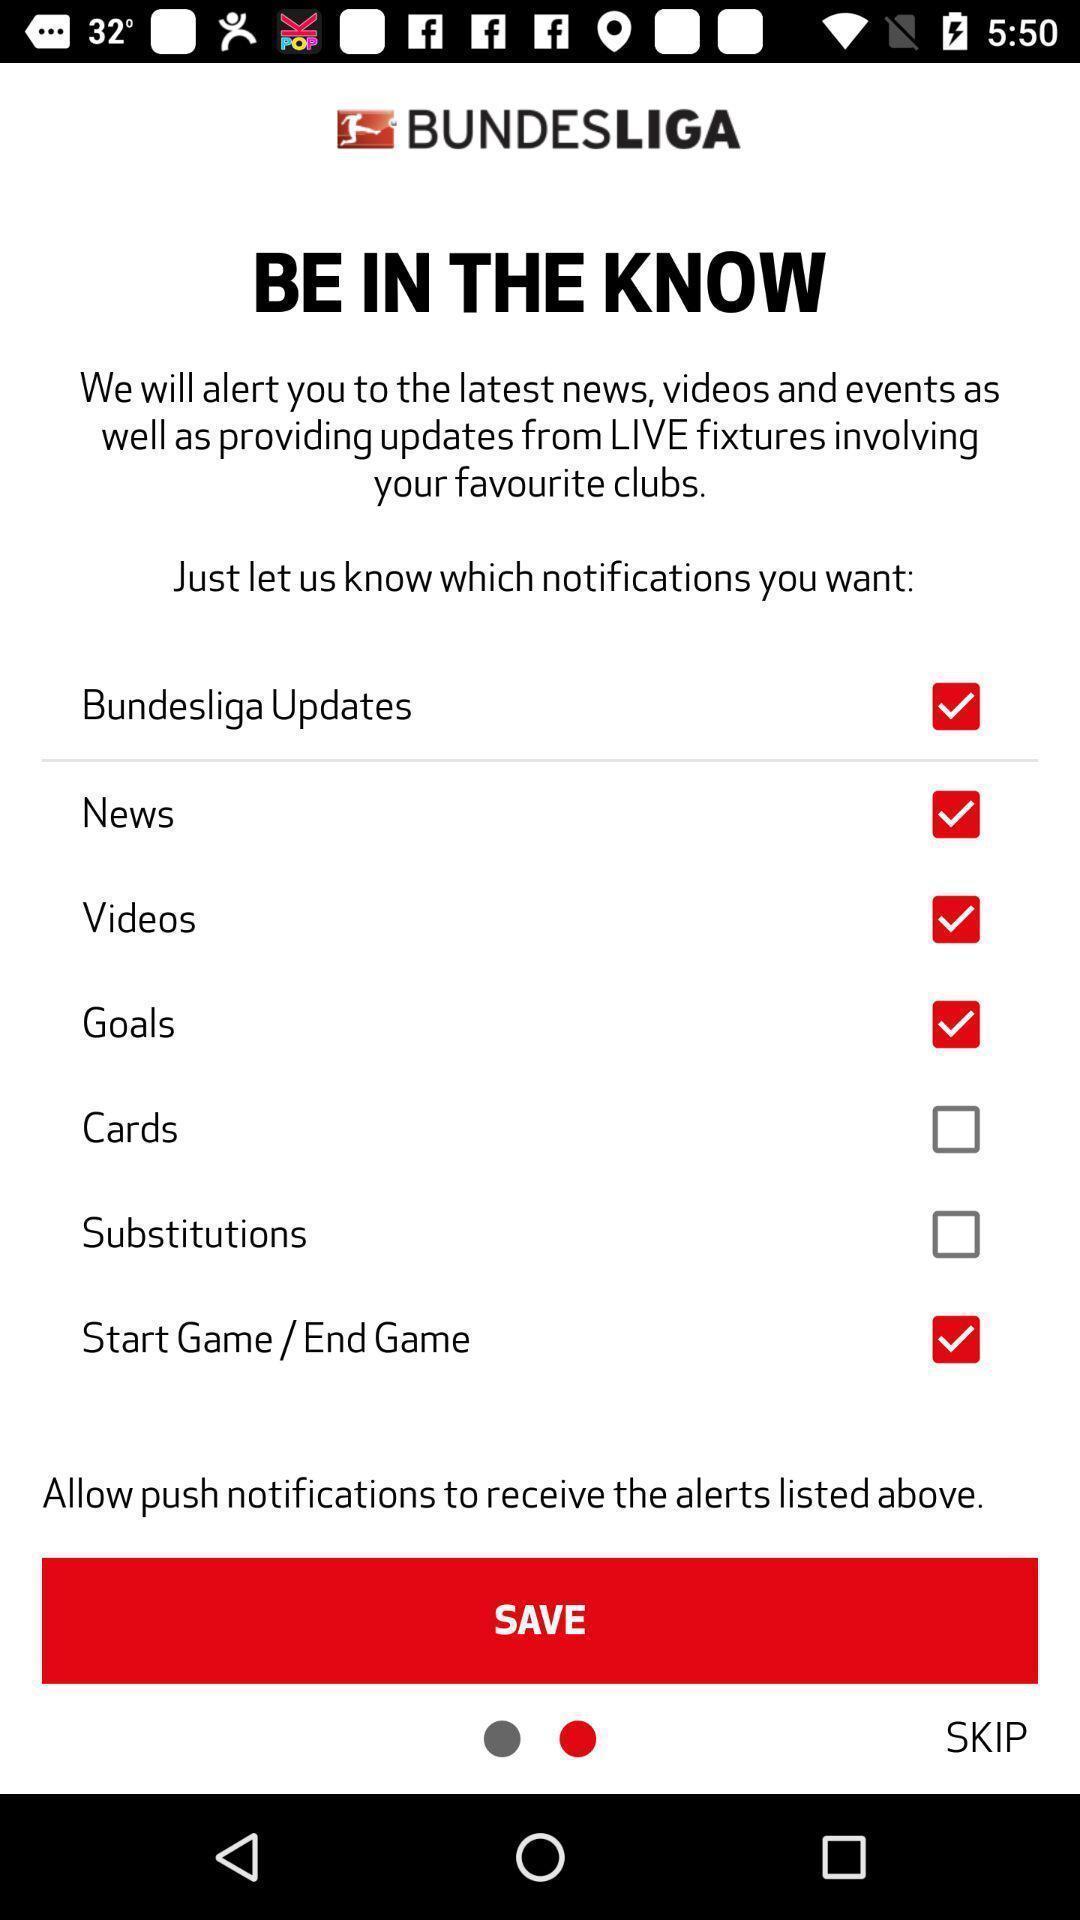Explain the elements present in this screenshot. Page to add different categories in the entertainment streaming app. 